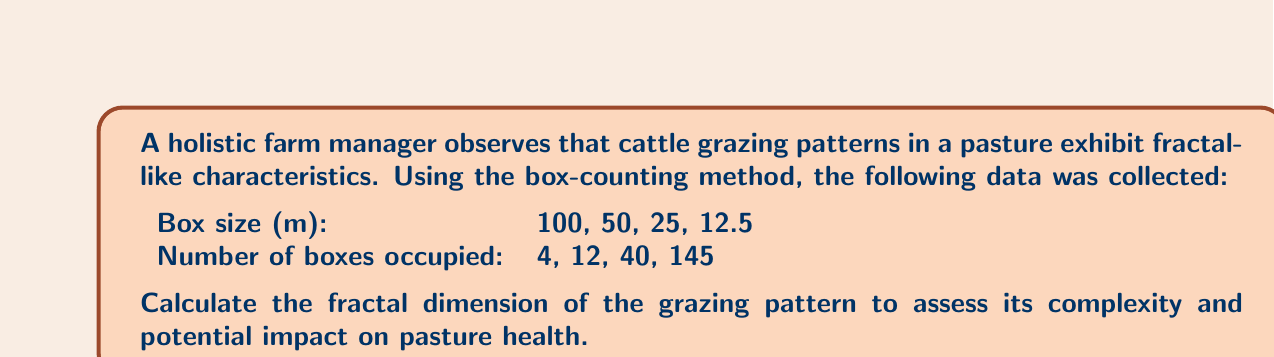Can you solve this math problem? To calculate the fractal dimension using the box-counting method, we follow these steps:

1. The box-counting dimension is defined as:

   $$D = \lim_{\epsilon \to 0} \frac{\log N(\epsilon)}{\log(1/\epsilon)}$$

   where $N(\epsilon)$ is the number of boxes of size $\epsilon$ needed to cover the fractal.

2. In practice, we use the slope of the log-log plot of $N(\epsilon)$ vs. $1/\epsilon$.

3. Let's create a table with the necessary calculations:

   | $\epsilon$ (m) | $1/\epsilon$ | $N(\epsilon)$ | $\log(1/\epsilon)$ | $\log N(\epsilon)$ |
   |----------------|--------------|---------------|--------------------|--------------------|
   | 100            | 0.01         | 4             | -2                 | 0.6021             |
   | 50             | 0.02         | 12            | -1.6990            | 1.0792             |
   | 25             | 0.04         | 40            | -1.3979            | 1.6021             |
   | 12.5           | 0.08         | 145           | -1.0969            | 2.1614             |

4. Plot $\log N(\epsilon)$ vs. $\log(1/\epsilon)$ and find the slope:

   [asy]
   import graph;
   size(200,200);
   
   real[] x = {-2,-1.699,-1.3979,-1.0969};
   real[] y = {0.6021,1.0792,1.6021,2.1614};
   
   dot(x,y);
   
   draw(graph(x,y));
   
   xaxis("log(1/ε)",LeftTicks);
   yaxis("log N(ε)",RightTicks);
   [/asy]

5. The slope of this line is the fractal dimension. We can calculate it using the least squares method:

   $$D = \frac{n\sum xy - \sum x \sum y}{n\sum x^2 - (\sum x)^2}$$

   where $x = \log(1/\epsilon)$ and $y = \log N(\epsilon)$

6. Plugging in the values:

   $$D = \frac{4(-11.3175) - (-6.1938)(5.4448)}{4(10.2916) - (-6.1938)^2} \approx 1.7184$$

This fractal dimension indicates a complex grazing pattern that covers more area than a simple line (D=1) but less than a filled plane (D=2), suggesting a balance between intensive and extensive grazing behaviors.
Answer: $D \approx 1.7184$ 